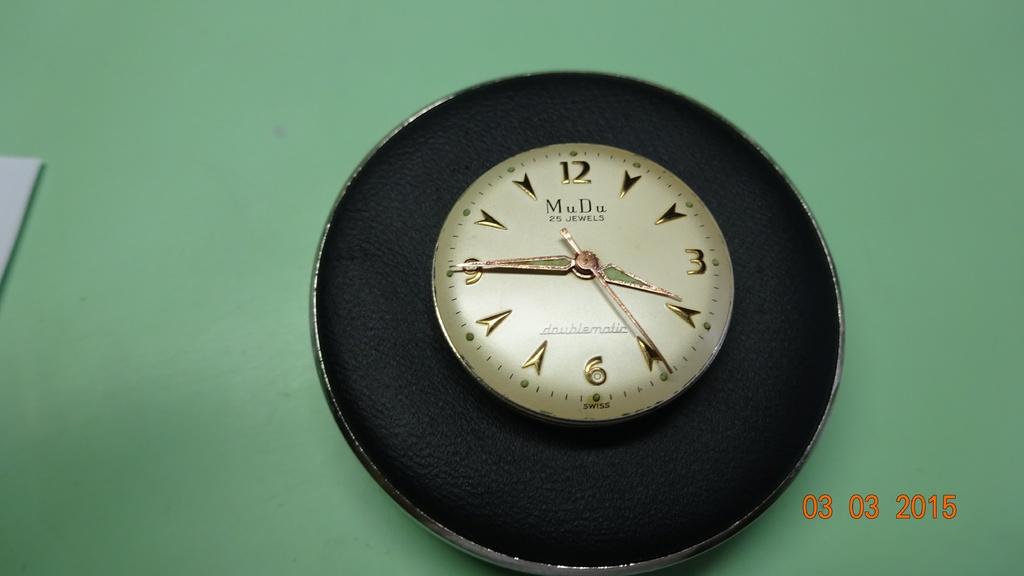What time does the clock show?
Provide a succinct answer. 3:45. What date was this picture taken?
Offer a terse response. 03 03 2015. 